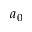Convert formula to latex. <formula><loc_0><loc_0><loc_500><loc_500>a _ { 0 }</formula> 